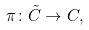<formula> <loc_0><loc_0><loc_500><loc_500>\pi \colon \tilde { C } \rightarrow C ,</formula> 